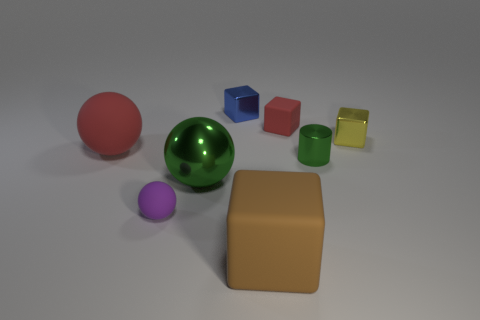How would you describe the lighting and shadow effects in the image, and what do they suggest about the light source? The lighting in the image appears to be diffuse, creating soft shadows with feathered edges. These shadows are cast primarily to the right of the objects, suggesting that the light source is located to the left-hand side of the scene. The evenness of the light and the softness of the shadows indicate an ambient light source, such as one that might be found in a studio setting. 